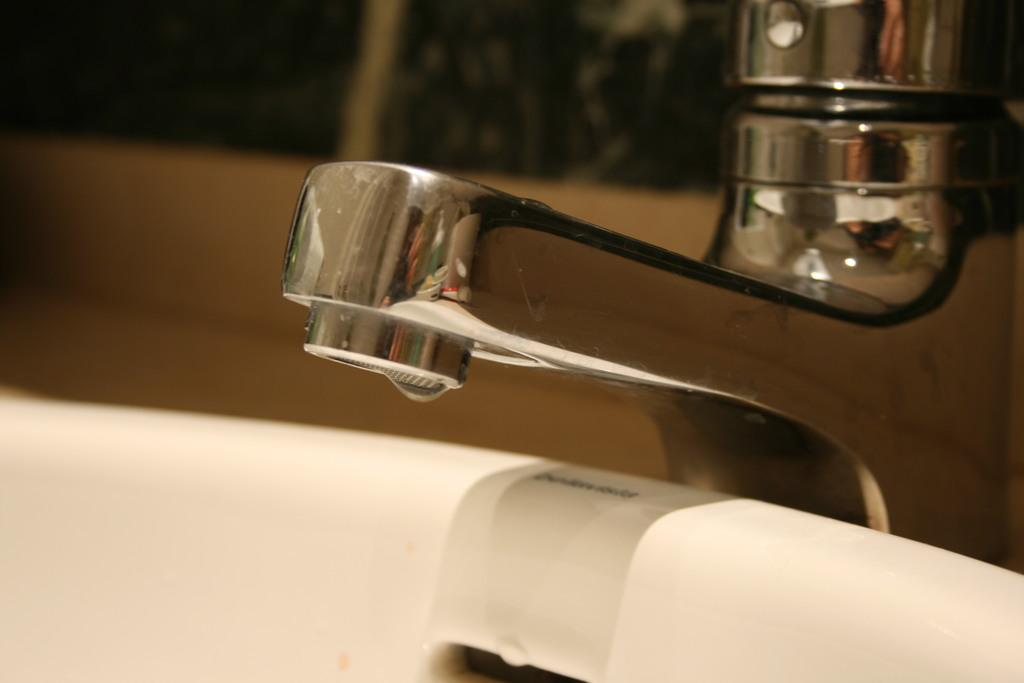What is the main object in the center of the image? There is a sink in the middle of the image. What is located at the top of the sink? There is a metal tap at the top of the sink. What decision is being made by the camera in the image? There is no camera present in the image, so no decision is being made. 